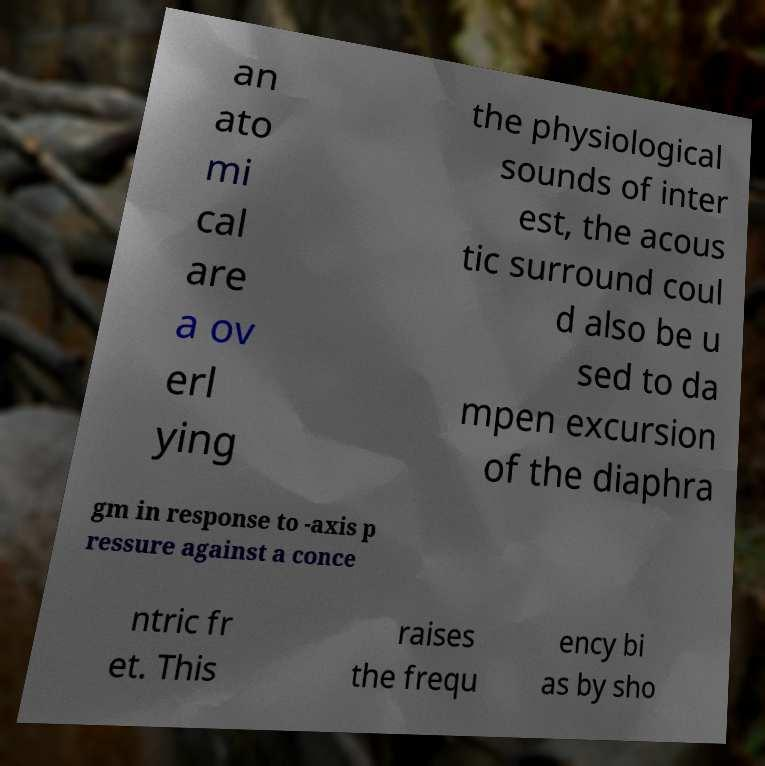Please identify and transcribe the text found in this image. an ato mi cal are a ov erl ying the physiological sounds of inter est, the acous tic surround coul d also be u sed to da mpen excursion of the diaphra gm in response to -axis p ressure against a conce ntric fr et. This raises the frequ ency bi as by sho 